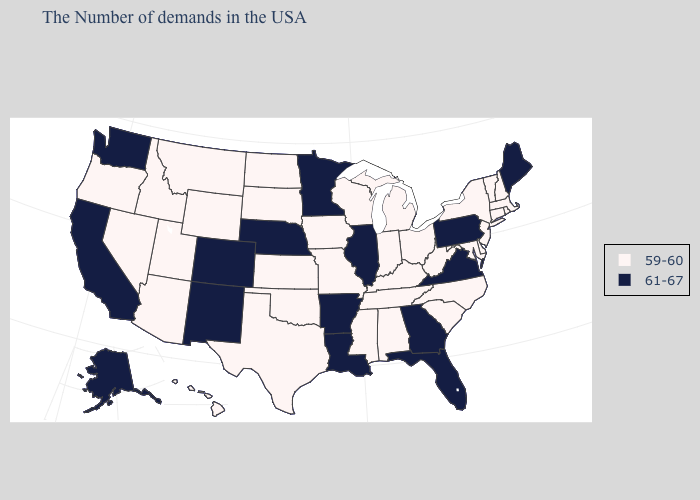Does Vermont have the lowest value in the USA?
Answer briefly. Yes. Name the states that have a value in the range 59-60?
Give a very brief answer. Massachusetts, Rhode Island, New Hampshire, Vermont, Connecticut, New York, New Jersey, Delaware, Maryland, North Carolina, South Carolina, West Virginia, Ohio, Michigan, Kentucky, Indiana, Alabama, Tennessee, Wisconsin, Mississippi, Missouri, Iowa, Kansas, Oklahoma, Texas, South Dakota, North Dakota, Wyoming, Utah, Montana, Arizona, Idaho, Nevada, Oregon, Hawaii. What is the highest value in the USA?
Write a very short answer. 61-67. Does Minnesota have the lowest value in the USA?
Concise answer only. No. What is the lowest value in the South?
Write a very short answer. 59-60. What is the highest value in the USA?
Be succinct. 61-67. What is the highest value in the Northeast ?
Short answer required. 61-67. Does Alabama have the same value as Nebraska?
Quick response, please. No. Which states have the lowest value in the West?
Concise answer only. Wyoming, Utah, Montana, Arizona, Idaho, Nevada, Oregon, Hawaii. What is the highest value in states that border Nevada?
Answer briefly. 61-67. Does Wyoming have the same value as Alaska?
Write a very short answer. No. Does the first symbol in the legend represent the smallest category?
Be succinct. Yes. Does New Mexico have the lowest value in the USA?
Write a very short answer. No. Name the states that have a value in the range 59-60?
Short answer required. Massachusetts, Rhode Island, New Hampshire, Vermont, Connecticut, New York, New Jersey, Delaware, Maryland, North Carolina, South Carolina, West Virginia, Ohio, Michigan, Kentucky, Indiana, Alabama, Tennessee, Wisconsin, Mississippi, Missouri, Iowa, Kansas, Oklahoma, Texas, South Dakota, North Dakota, Wyoming, Utah, Montana, Arizona, Idaho, Nevada, Oregon, Hawaii. What is the highest value in the South ?
Write a very short answer. 61-67. 